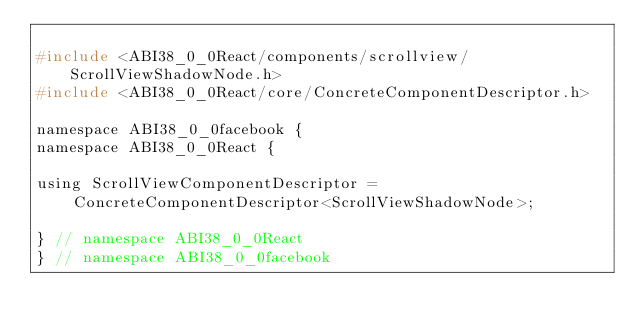Convert code to text. <code><loc_0><loc_0><loc_500><loc_500><_C_>
#include <ABI38_0_0React/components/scrollview/ScrollViewShadowNode.h>
#include <ABI38_0_0React/core/ConcreteComponentDescriptor.h>

namespace ABI38_0_0facebook {
namespace ABI38_0_0React {

using ScrollViewComponentDescriptor =
    ConcreteComponentDescriptor<ScrollViewShadowNode>;

} // namespace ABI38_0_0React
} // namespace ABI38_0_0facebook
</code> 